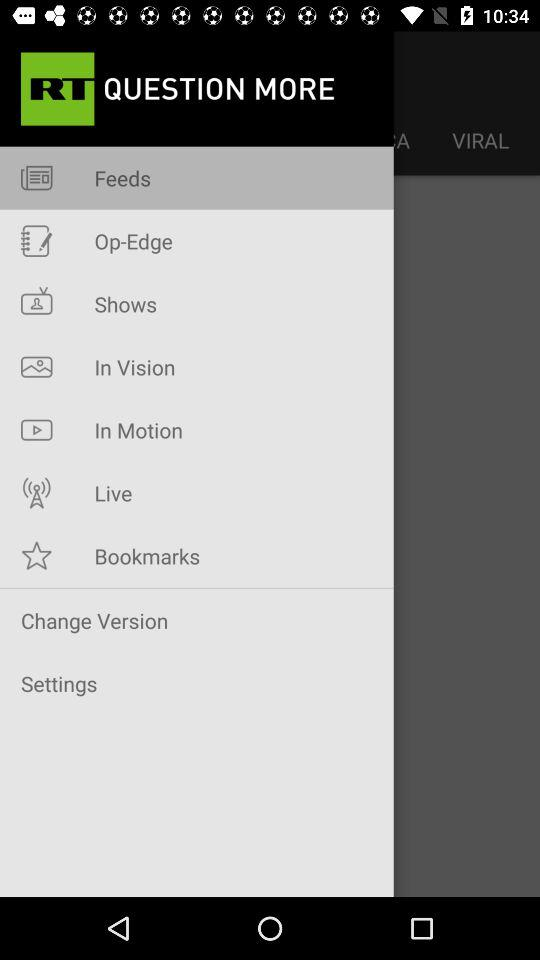What is the app's name? The app's name is "RT QUESTION MORE". 